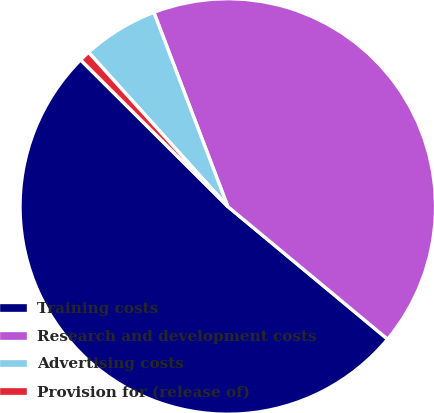<chart> <loc_0><loc_0><loc_500><loc_500><pie_chart><fcel>Training costs<fcel>Research and development costs<fcel>Advertising costs<fcel>Provision for (release of)<nl><fcel>51.44%<fcel>41.82%<fcel>5.9%<fcel>0.84%<nl></chart> 